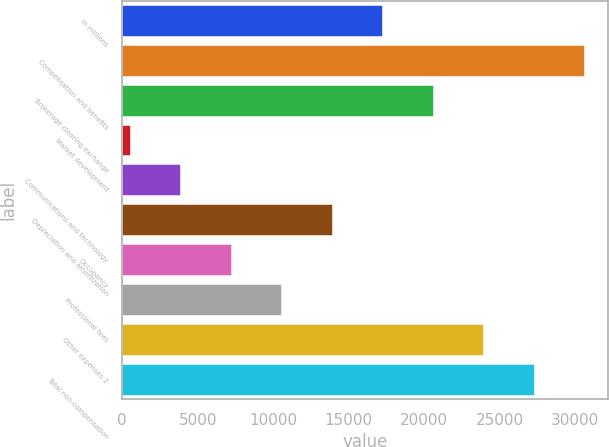<chart> <loc_0><loc_0><loc_500><loc_500><bar_chart><fcel>in millions<fcel>Compensation and benefits<fcel>Brokerage clearing exchange<fcel>Market development<fcel>Communications and technology<fcel>Depreciation and amortization<fcel>Occupancy<fcel>Professional fees<fcel>Other expenses 2<fcel>Total non-compensation<nl><fcel>17274.5<fcel>30654.9<fcel>20619.6<fcel>549<fcel>3894.1<fcel>13929.4<fcel>7239.2<fcel>10584.3<fcel>23964.7<fcel>27309.8<nl></chart> 